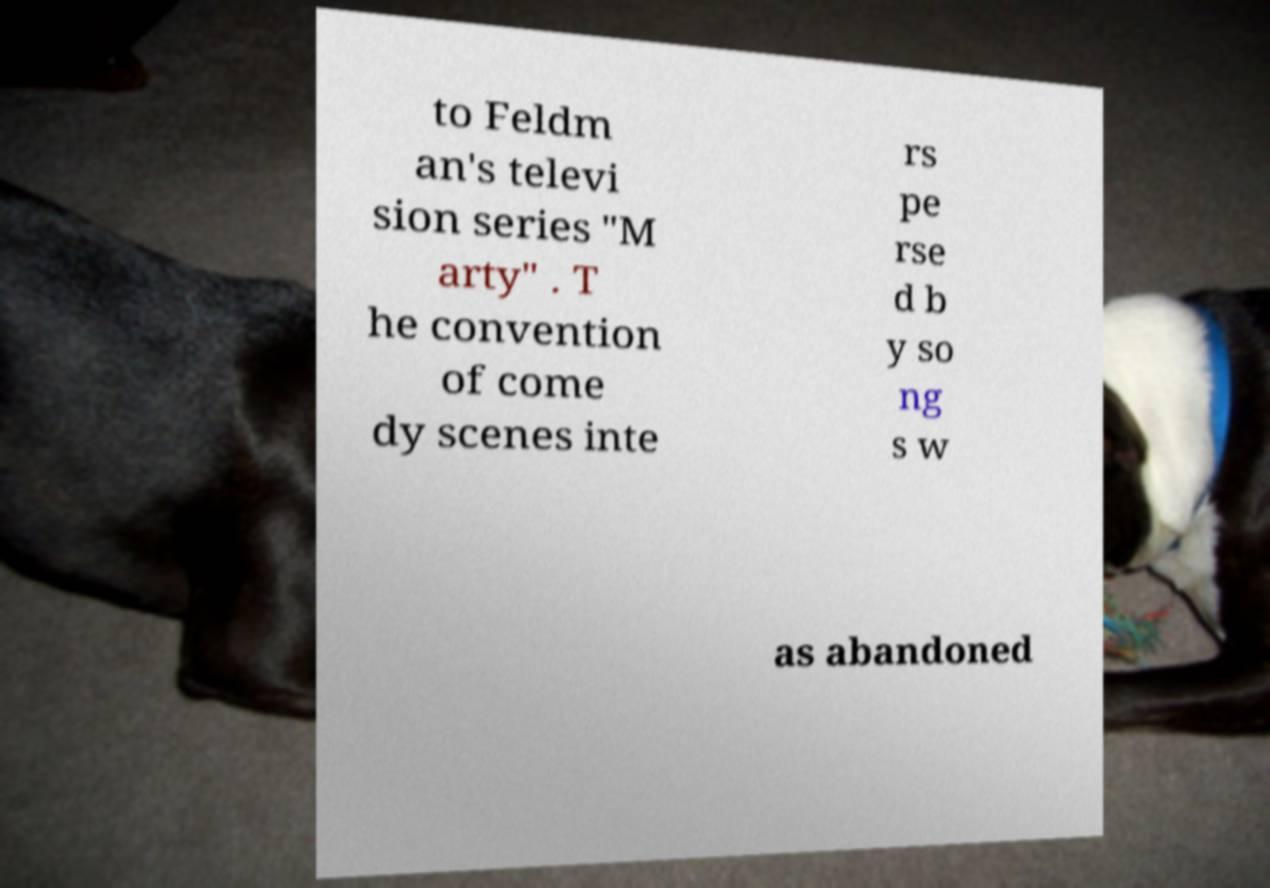For documentation purposes, I need the text within this image transcribed. Could you provide that? to Feldm an's televi sion series "M arty" . T he convention of come dy scenes inte rs pe rse d b y so ng s w as abandoned 